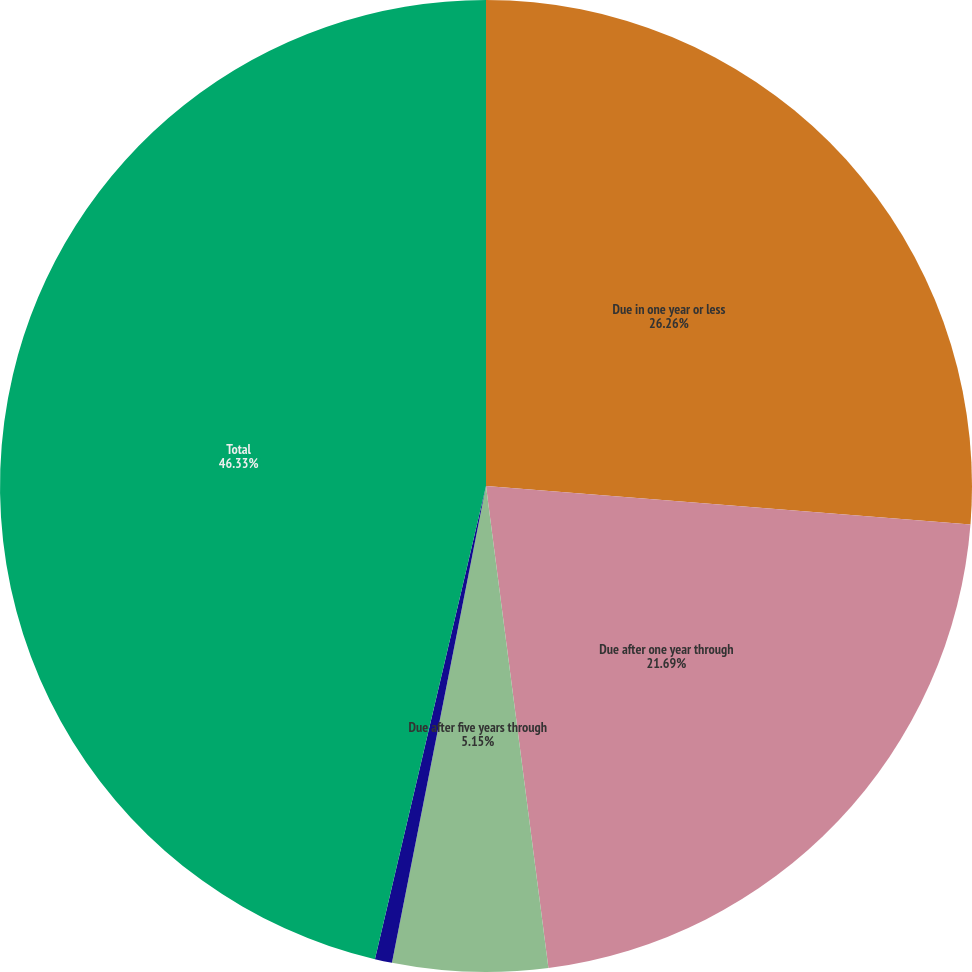Convert chart. <chart><loc_0><loc_0><loc_500><loc_500><pie_chart><fcel>Due in one year or less<fcel>Due after one year through<fcel>Due after five years through<fcel>Due after 10 years<fcel>Total<nl><fcel>26.26%<fcel>21.69%<fcel>5.15%<fcel>0.57%<fcel>46.33%<nl></chart> 